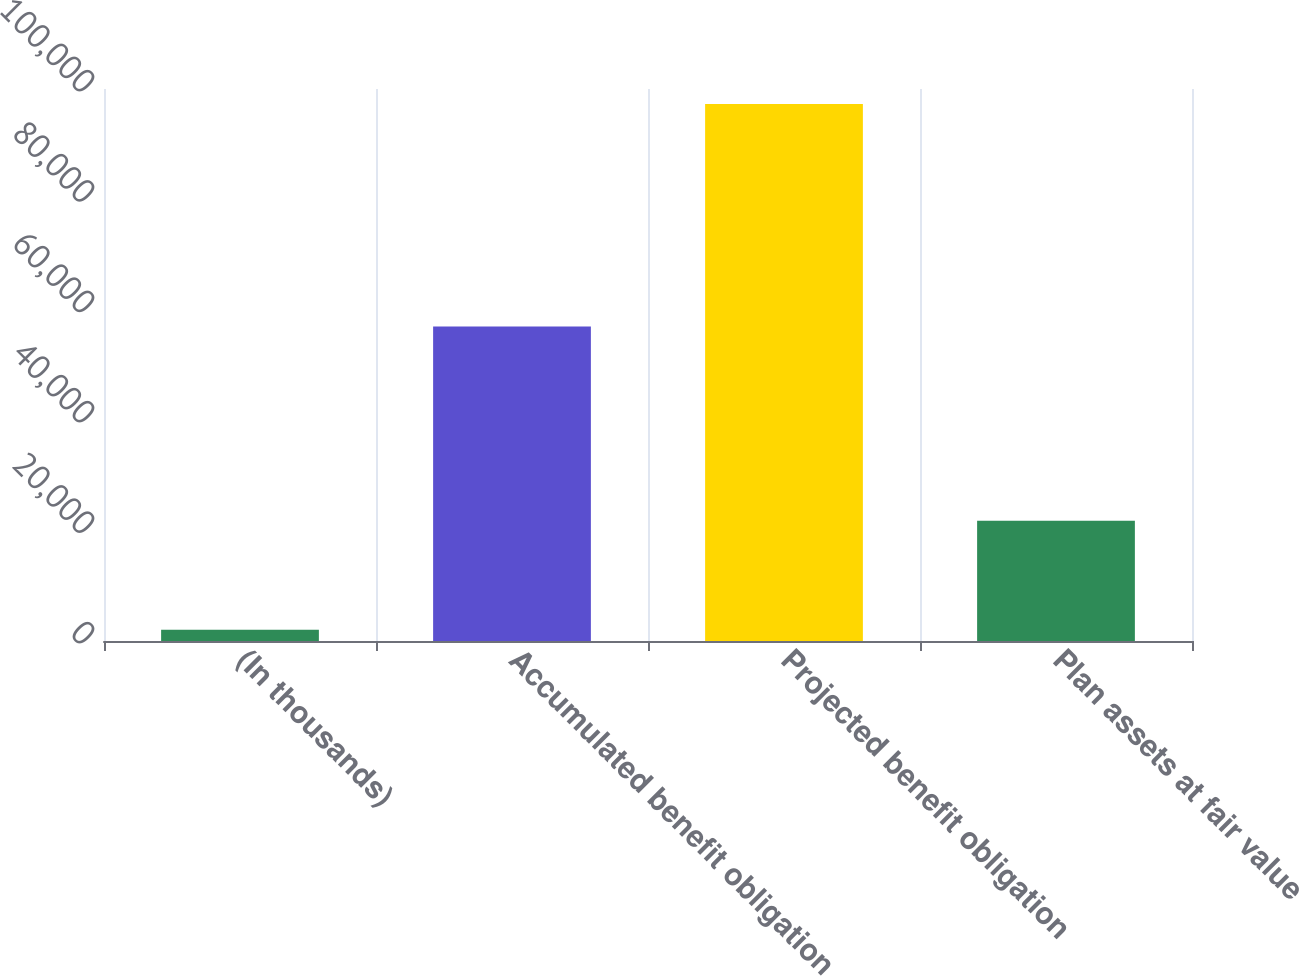Convert chart to OTSL. <chart><loc_0><loc_0><loc_500><loc_500><bar_chart><fcel>(In thousands)<fcel>Accumulated benefit obligation<fcel>Projected benefit obligation<fcel>Plan assets at fair value<nl><fcel>2017<fcel>56967<fcel>97265<fcel>21780<nl></chart> 